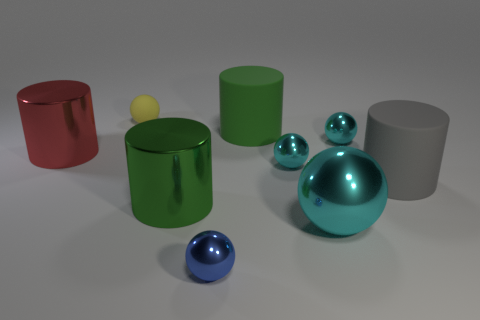Subtract all yellow rubber balls. How many balls are left? 4 Subtract all balls. How many objects are left? 4 Subtract 3 spheres. How many spheres are left? 2 Subtract all red cylinders. How many cylinders are left? 3 Subtract 0 purple cubes. How many objects are left? 9 Subtract all blue cylinders. Subtract all brown blocks. How many cylinders are left? 4 Subtract all green balls. How many purple cylinders are left? 0 Subtract all rubber things. Subtract all large metal objects. How many objects are left? 3 Add 6 red cylinders. How many red cylinders are left? 7 Add 2 large red cylinders. How many large red cylinders exist? 3 